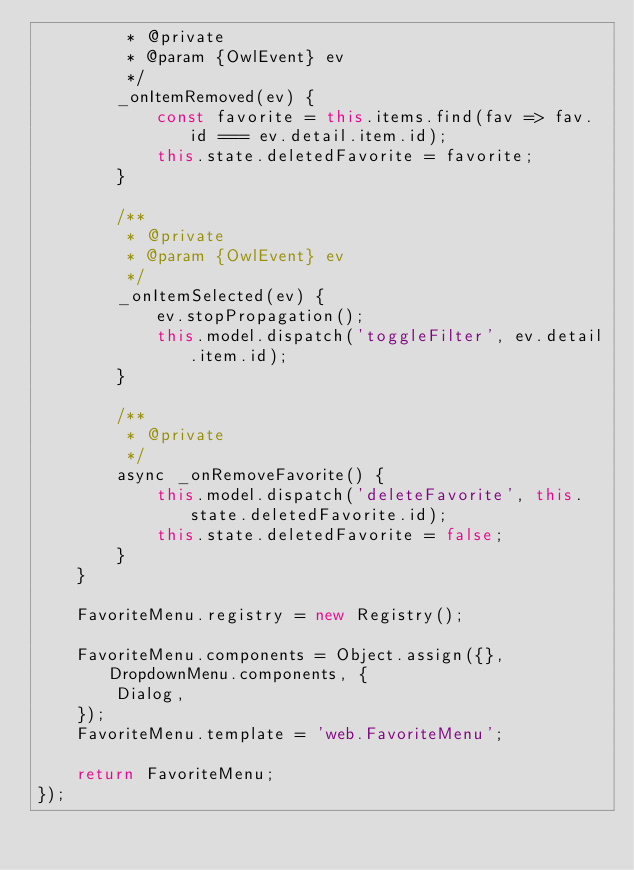Convert code to text. <code><loc_0><loc_0><loc_500><loc_500><_JavaScript_>         * @private
         * @param {OwlEvent} ev
         */
        _onItemRemoved(ev) {
            const favorite = this.items.find(fav => fav.id === ev.detail.item.id);
            this.state.deletedFavorite = favorite;
        }

        /**
         * @private
         * @param {OwlEvent} ev
         */
        _onItemSelected(ev) {
            ev.stopPropagation();
            this.model.dispatch('toggleFilter', ev.detail.item.id);
        }

        /**
         * @private
         */
        async _onRemoveFavorite() {
            this.model.dispatch('deleteFavorite', this.state.deletedFavorite.id);
            this.state.deletedFavorite = false;
        }
    }

    FavoriteMenu.registry = new Registry();

    FavoriteMenu.components = Object.assign({}, DropdownMenu.components, {
        Dialog,
    });
    FavoriteMenu.template = 'web.FavoriteMenu';

    return FavoriteMenu;
});
</code> 